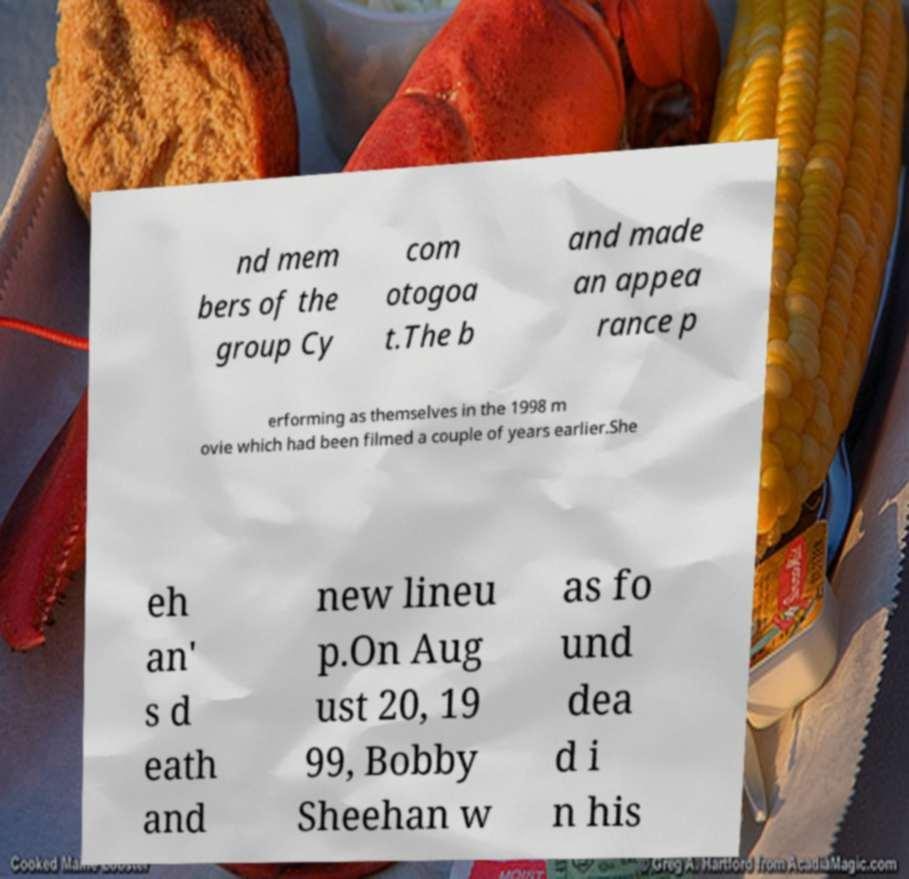Please read and relay the text visible in this image. What does it say? nd mem bers of the group Cy com otogoa t.The b and made an appea rance p erforming as themselves in the 1998 m ovie which had been filmed a couple of years earlier.She eh an' s d eath and new lineu p.On Aug ust 20, 19 99, Bobby Sheehan w as fo und dea d i n his 